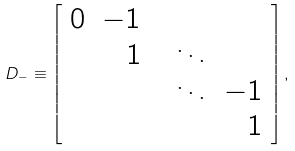Convert formula to latex. <formula><loc_0><loc_0><loc_500><loc_500>D _ { - } \equiv \left [ \begin{array} { r r r r r } 0 & - 1 & & & \\ & 1 & & \ddots & \\ & & & \ddots & - 1 \\ & & & & 1 \end{array} \right ] ,</formula> 